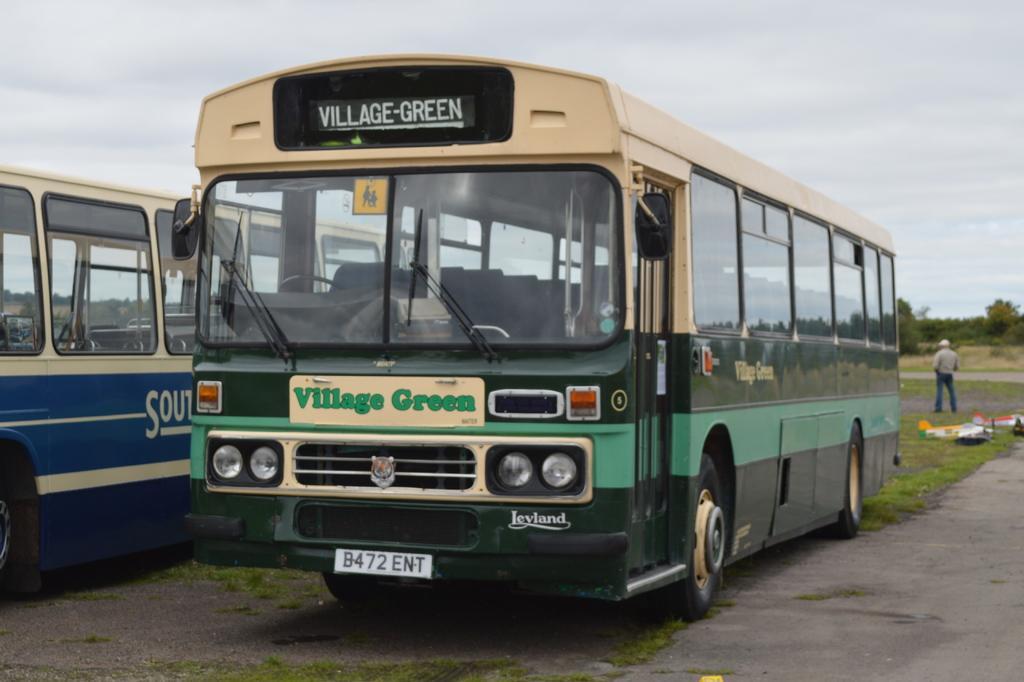How would you summarize this image in a sentence or two? This image is taken outdoors. At the top of the image there is the sky with clouds. In the background there are many trees and plants. At the bottom of the image there is a ground with grass on it. On the right side of the image a man is standing on the ground and there are a few things on the ground. In the middle of the image two buses are parked on the ground. There is a text on the buses. 